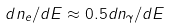<formula> <loc_0><loc_0><loc_500><loc_500>d n _ { e } / d E \approx 0 . 5 d n _ { \gamma } / d E</formula> 